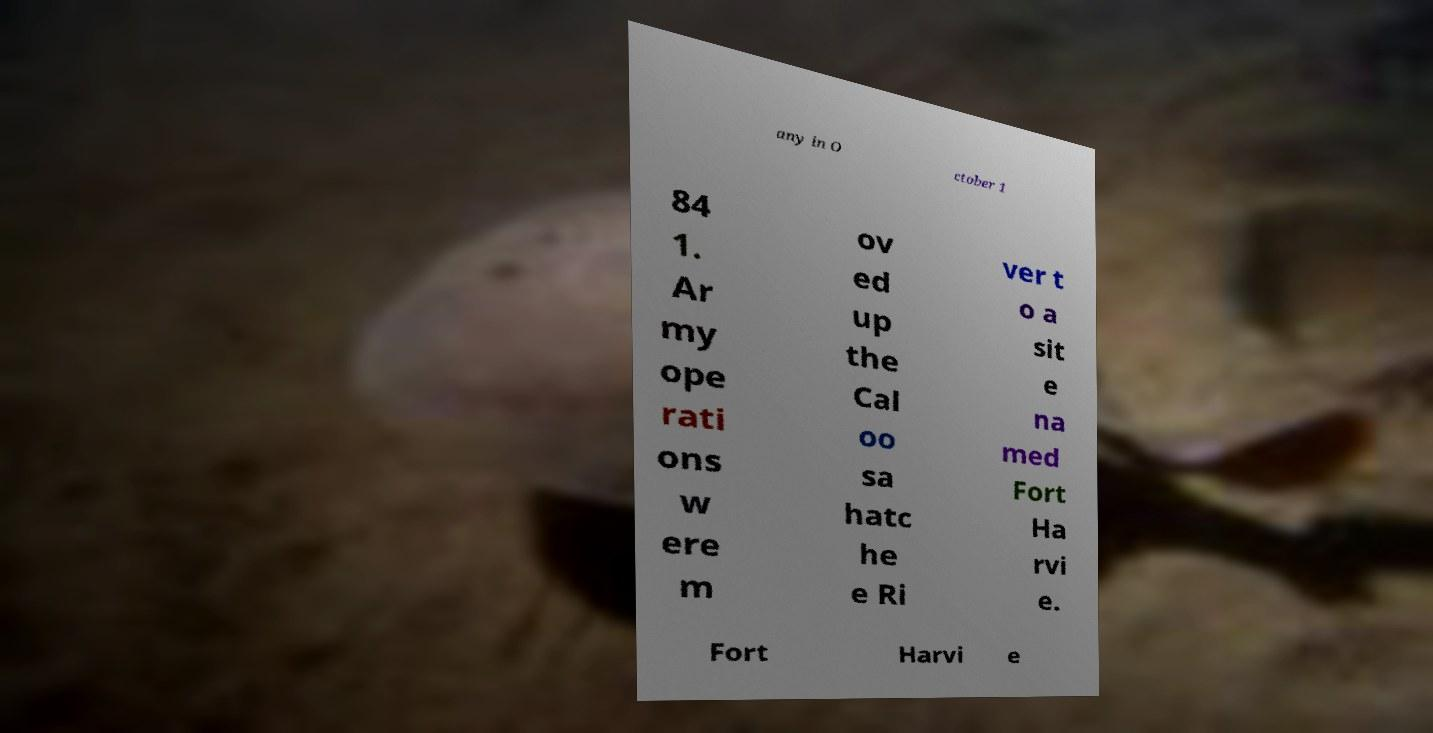Please read and relay the text visible in this image. What does it say? any in O ctober 1 84 1. Ar my ope rati ons w ere m ov ed up the Cal oo sa hatc he e Ri ver t o a sit e na med Fort Ha rvi e. Fort Harvi e 